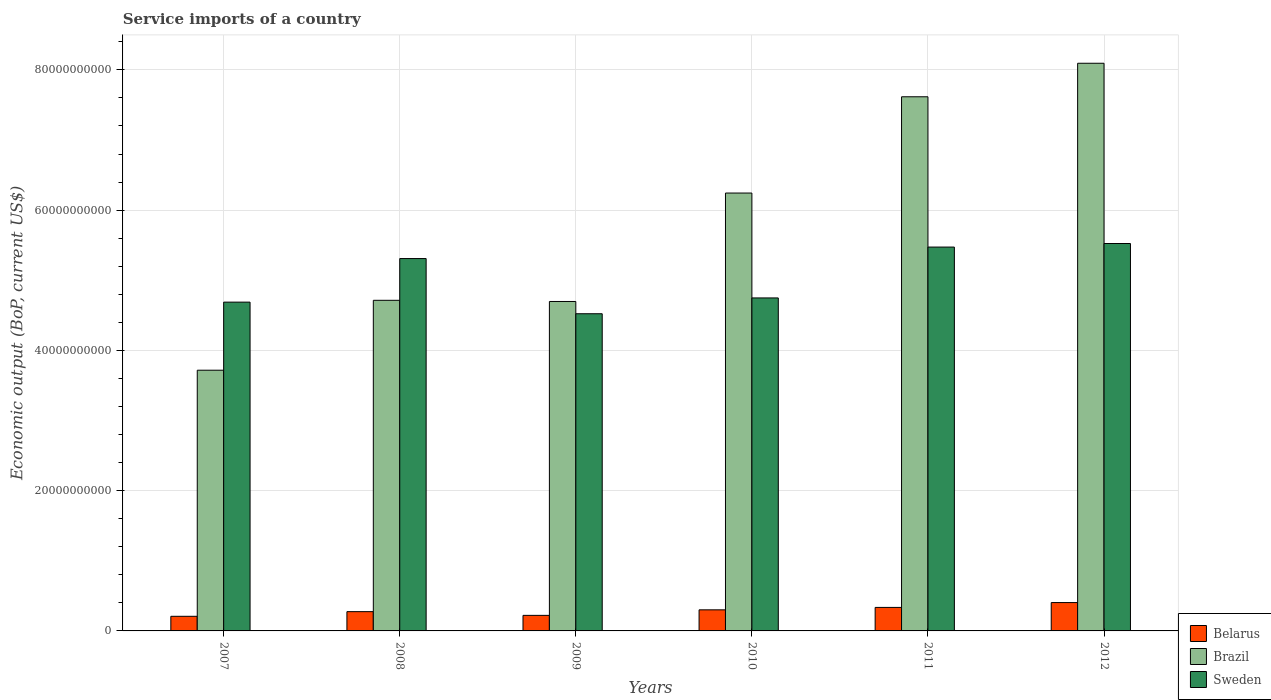How many groups of bars are there?
Give a very brief answer. 6. Are the number of bars on each tick of the X-axis equal?
Your response must be concise. Yes. How many bars are there on the 1st tick from the left?
Provide a short and direct response. 3. How many bars are there on the 4th tick from the right?
Your response must be concise. 3. What is the service imports in Sweden in 2007?
Provide a short and direct response. 4.69e+1. Across all years, what is the maximum service imports in Sweden?
Your answer should be very brief. 5.52e+1. Across all years, what is the minimum service imports in Brazil?
Offer a terse response. 3.72e+1. In which year was the service imports in Belarus maximum?
Your answer should be compact. 2012. What is the total service imports in Brazil in the graph?
Provide a short and direct response. 3.51e+11. What is the difference between the service imports in Brazil in 2009 and that in 2010?
Make the answer very short. -1.55e+1. What is the difference between the service imports in Belarus in 2011 and the service imports in Brazil in 2009?
Make the answer very short. -4.36e+1. What is the average service imports in Belarus per year?
Give a very brief answer. 2.91e+09. In the year 2007, what is the difference between the service imports in Belarus and service imports in Brazil?
Offer a terse response. -3.51e+1. What is the ratio of the service imports in Belarus in 2008 to that in 2009?
Offer a terse response. 1.24. Is the service imports in Belarus in 2009 less than that in 2011?
Keep it short and to the point. Yes. What is the difference between the highest and the second highest service imports in Brazil?
Keep it short and to the point. 4.78e+09. What is the difference between the highest and the lowest service imports in Belarus?
Offer a terse response. 1.96e+09. In how many years, is the service imports in Brazil greater than the average service imports in Brazil taken over all years?
Provide a short and direct response. 3. What does the 1st bar from the left in 2010 represents?
Your response must be concise. Belarus. Is it the case that in every year, the sum of the service imports in Belarus and service imports in Sweden is greater than the service imports in Brazil?
Ensure brevity in your answer.  No. How many bars are there?
Your answer should be compact. 18. Are all the bars in the graph horizontal?
Your answer should be compact. No. Does the graph contain grids?
Give a very brief answer. Yes. How are the legend labels stacked?
Give a very brief answer. Vertical. What is the title of the graph?
Your response must be concise. Service imports of a country. Does "Mali" appear as one of the legend labels in the graph?
Give a very brief answer. No. What is the label or title of the Y-axis?
Your response must be concise. Economic output (BoP, current US$). What is the Economic output (BoP, current US$) in Belarus in 2007?
Your answer should be compact. 2.08e+09. What is the Economic output (BoP, current US$) in Brazil in 2007?
Make the answer very short. 3.72e+1. What is the Economic output (BoP, current US$) in Sweden in 2007?
Offer a very short reply. 4.69e+1. What is the Economic output (BoP, current US$) of Belarus in 2008?
Your response must be concise. 2.75e+09. What is the Economic output (BoP, current US$) of Brazil in 2008?
Your response must be concise. 4.71e+1. What is the Economic output (BoP, current US$) of Sweden in 2008?
Provide a short and direct response. 5.31e+1. What is the Economic output (BoP, current US$) in Belarus in 2009?
Ensure brevity in your answer.  2.22e+09. What is the Economic output (BoP, current US$) of Brazil in 2009?
Your response must be concise. 4.70e+1. What is the Economic output (BoP, current US$) of Sweden in 2009?
Offer a very short reply. 4.52e+1. What is the Economic output (BoP, current US$) in Belarus in 2010?
Ensure brevity in your answer.  3.01e+09. What is the Economic output (BoP, current US$) in Brazil in 2010?
Ensure brevity in your answer.  6.24e+1. What is the Economic output (BoP, current US$) of Sweden in 2010?
Make the answer very short. 4.75e+1. What is the Economic output (BoP, current US$) of Belarus in 2011?
Offer a terse response. 3.35e+09. What is the Economic output (BoP, current US$) of Brazil in 2011?
Give a very brief answer. 7.62e+1. What is the Economic output (BoP, current US$) in Sweden in 2011?
Offer a terse response. 5.47e+1. What is the Economic output (BoP, current US$) in Belarus in 2012?
Offer a very short reply. 4.04e+09. What is the Economic output (BoP, current US$) of Brazil in 2012?
Provide a short and direct response. 8.09e+1. What is the Economic output (BoP, current US$) in Sweden in 2012?
Your answer should be very brief. 5.52e+1. Across all years, what is the maximum Economic output (BoP, current US$) of Belarus?
Your response must be concise. 4.04e+09. Across all years, what is the maximum Economic output (BoP, current US$) of Brazil?
Offer a terse response. 8.09e+1. Across all years, what is the maximum Economic output (BoP, current US$) in Sweden?
Give a very brief answer. 5.52e+1. Across all years, what is the minimum Economic output (BoP, current US$) in Belarus?
Your answer should be compact. 2.08e+09. Across all years, what is the minimum Economic output (BoP, current US$) of Brazil?
Your answer should be compact. 3.72e+1. Across all years, what is the minimum Economic output (BoP, current US$) in Sweden?
Your answer should be compact. 4.52e+1. What is the total Economic output (BoP, current US$) in Belarus in the graph?
Your response must be concise. 1.75e+1. What is the total Economic output (BoP, current US$) in Brazil in the graph?
Offer a very short reply. 3.51e+11. What is the total Economic output (BoP, current US$) in Sweden in the graph?
Your answer should be very brief. 3.03e+11. What is the difference between the Economic output (BoP, current US$) of Belarus in 2007 and that in 2008?
Offer a terse response. -6.63e+08. What is the difference between the Economic output (BoP, current US$) of Brazil in 2007 and that in 2008?
Your answer should be compact. -9.97e+09. What is the difference between the Economic output (BoP, current US$) of Sweden in 2007 and that in 2008?
Make the answer very short. -6.21e+09. What is the difference between the Economic output (BoP, current US$) of Belarus in 2007 and that in 2009?
Make the answer very short. -1.33e+08. What is the difference between the Economic output (BoP, current US$) of Brazil in 2007 and that in 2009?
Your answer should be compact. -9.80e+09. What is the difference between the Economic output (BoP, current US$) in Sweden in 2007 and that in 2009?
Your response must be concise. 1.65e+09. What is the difference between the Economic output (BoP, current US$) in Belarus in 2007 and that in 2010?
Give a very brief answer. -9.22e+08. What is the difference between the Economic output (BoP, current US$) in Brazil in 2007 and that in 2010?
Your answer should be compact. -2.53e+1. What is the difference between the Economic output (BoP, current US$) of Sweden in 2007 and that in 2010?
Offer a terse response. -5.99e+08. What is the difference between the Economic output (BoP, current US$) of Belarus in 2007 and that in 2011?
Ensure brevity in your answer.  -1.27e+09. What is the difference between the Economic output (BoP, current US$) in Brazil in 2007 and that in 2011?
Offer a terse response. -3.90e+1. What is the difference between the Economic output (BoP, current US$) in Sweden in 2007 and that in 2011?
Offer a terse response. -7.85e+09. What is the difference between the Economic output (BoP, current US$) of Belarus in 2007 and that in 2012?
Ensure brevity in your answer.  -1.96e+09. What is the difference between the Economic output (BoP, current US$) in Brazil in 2007 and that in 2012?
Make the answer very short. -4.38e+1. What is the difference between the Economic output (BoP, current US$) of Sweden in 2007 and that in 2012?
Your response must be concise. -8.36e+09. What is the difference between the Economic output (BoP, current US$) of Belarus in 2008 and that in 2009?
Keep it short and to the point. 5.30e+08. What is the difference between the Economic output (BoP, current US$) of Brazil in 2008 and that in 2009?
Offer a terse response. 1.66e+08. What is the difference between the Economic output (BoP, current US$) in Sweden in 2008 and that in 2009?
Offer a very short reply. 7.87e+09. What is the difference between the Economic output (BoP, current US$) in Belarus in 2008 and that in 2010?
Ensure brevity in your answer.  -2.59e+08. What is the difference between the Economic output (BoP, current US$) in Brazil in 2008 and that in 2010?
Give a very brief answer. -1.53e+1. What is the difference between the Economic output (BoP, current US$) of Sweden in 2008 and that in 2010?
Offer a very short reply. 5.61e+09. What is the difference between the Economic output (BoP, current US$) of Belarus in 2008 and that in 2011?
Your answer should be very brief. -6.04e+08. What is the difference between the Economic output (BoP, current US$) of Brazil in 2008 and that in 2011?
Make the answer very short. -2.90e+1. What is the difference between the Economic output (BoP, current US$) in Sweden in 2008 and that in 2011?
Give a very brief answer. -1.64e+09. What is the difference between the Economic output (BoP, current US$) in Belarus in 2008 and that in 2012?
Offer a very short reply. -1.30e+09. What is the difference between the Economic output (BoP, current US$) of Brazil in 2008 and that in 2012?
Make the answer very short. -3.38e+1. What is the difference between the Economic output (BoP, current US$) of Sweden in 2008 and that in 2012?
Give a very brief answer. -2.15e+09. What is the difference between the Economic output (BoP, current US$) in Belarus in 2009 and that in 2010?
Your response must be concise. -7.89e+08. What is the difference between the Economic output (BoP, current US$) in Brazil in 2009 and that in 2010?
Offer a very short reply. -1.55e+1. What is the difference between the Economic output (BoP, current US$) in Sweden in 2009 and that in 2010?
Offer a very short reply. -2.25e+09. What is the difference between the Economic output (BoP, current US$) of Belarus in 2009 and that in 2011?
Make the answer very short. -1.13e+09. What is the difference between the Economic output (BoP, current US$) of Brazil in 2009 and that in 2011?
Provide a short and direct response. -2.92e+1. What is the difference between the Economic output (BoP, current US$) of Sweden in 2009 and that in 2011?
Offer a terse response. -9.51e+09. What is the difference between the Economic output (BoP, current US$) of Belarus in 2009 and that in 2012?
Keep it short and to the point. -1.83e+09. What is the difference between the Economic output (BoP, current US$) in Brazil in 2009 and that in 2012?
Ensure brevity in your answer.  -3.40e+1. What is the difference between the Economic output (BoP, current US$) of Sweden in 2009 and that in 2012?
Your response must be concise. -1.00e+1. What is the difference between the Economic output (BoP, current US$) in Belarus in 2010 and that in 2011?
Offer a very short reply. -3.45e+08. What is the difference between the Economic output (BoP, current US$) of Brazil in 2010 and that in 2011?
Your answer should be compact. -1.37e+1. What is the difference between the Economic output (BoP, current US$) in Sweden in 2010 and that in 2011?
Your response must be concise. -7.25e+09. What is the difference between the Economic output (BoP, current US$) of Belarus in 2010 and that in 2012?
Keep it short and to the point. -1.04e+09. What is the difference between the Economic output (BoP, current US$) of Brazil in 2010 and that in 2012?
Ensure brevity in your answer.  -1.85e+1. What is the difference between the Economic output (BoP, current US$) in Sweden in 2010 and that in 2012?
Your response must be concise. -7.76e+09. What is the difference between the Economic output (BoP, current US$) of Belarus in 2011 and that in 2012?
Your answer should be very brief. -6.92e+08. What is the difference between the Economic output (BoP, current US$) of Brazil in 2011 and that in 2012?
Give a very brief answer. -4.78e+09. What is the difference between the Economic output (BoP, current US$) of Sweden in 2011 and that in 2012?
Offer a very short reply. -5.08e+08. What is the difference between the Economic output (BoP, current US$) in Belarus in 2007 and the Economic output (BoP, current US$) in Brazil in 2008?
Offer a terse response. -4.51e+1. What is the difference between the Economic output (BoP, current US$) of Belarus in 2007 and the Economic output (BoP, current US$) of Sweden in 2008?
Give a very brief answer. -5.10e+1. What is the difference between the Economic output (BoP, current US$) in Brazil in 2007 and the Economic output (BoP, current US$) in Sweden in 2008?
Make the answer very short. -1.59e+1. What is the difference between the Economic output (BoP, current US$) in Belarus in 2007 and the Economic output (BoP, current US$) in Brazil in 2009?
Your answer should be compact. -4.49e+1. What is the difference between the Economic output (BoP, current US$) in Belarus in 2007 and the Economic output (BoP, current US$) in Sweden in 2009?
Provide a succinct answer. -4.31e+1. What is the difference between the Economic output (BoP, current US$) of Brazil in 2007 and the Economic output (BoP, current US$) of Sweden in 2009?
Your response must be concise. -8.05e+09. What is the difference between the Economic output (BoP, current US$) of Belarus in 2007 and the Economic output (BoP, current US$) of Brazil in 2010?
Offer a terse response. -6.03e+1. What is the difference between the Economic output (BoP, current US$) of Belarus in 2007 and the Economic output (BoP, current US$) of Sweden in 2010?
Provide a short and direct response. -4.54e+1. What is the difference between the Economic output (BoP, current US$) of Brazil in 2007 and the Economic output (BoP, current US$) of Sweden in 2010?
Keep it short and to the point. -1.03e+1. What is the difference between the Economic output (BoP, current US$) in Belarus in 2007 and the Economic output (BoP, current US$) in Brazil in 2011?
Keep it short and to the point. -7.41e+1. What is the difference between the Economic output (BoP, current US$) of Belarus in 2007 and the Economic output (BoP, current US$) of Sweden in 2011?
Your answer should be compact. -5.26e+1. What is the difference between the Economic output (BoP, current US$) of Brazil in 2007 and the Economic output (BoP, current US$) of Sweden in 2011?
Your answer should be compact. -1.76e+1. What is the difference between the Economic output (BoP, current US$) in Belarus in 2007 and the Economic output (BoP, current US$) in Brazil in 2012?
Provide a succinct answer. -7.89e+1. What is the difference between the Economic output (BoP, current US$) in Belarus in 2007 and the Economic output (BoP, current US$) in Sweden in 2012?
Offer a terse response. -5.32e+1. What is the difference between the Economic output (BoP, current US$) in Brazil in 2007 and the Economic output (BoP, current US$) in Sweden in 2012?
Your answer should be compact. -1.81e+1. What is the difference between the Economic output (BoP, current US$) in Belarus in 2008 and the Economic output (BoP, current US$) in Brazil in 2009?
Provide a succinct answer. -4.42e+1. What is the difference between the Economic output (BoP, current US$) of Belarus in 2008 and the Economic output (BoP, current US$) of Sweden in 2009?
Offer a very short reply. -4.25e+1. What is the difference between the Economic output (BoP, current US$) of Brazil in 2008 and the Economic output (BoP, current US$) of Sweden in 2009?
Keep it short and to the point. 1.92e+09. What is the difference between the Economic output (BoP, current US$) of Belarus in 2008 and the Economic output (BoP, current US$) of Brazil in 2010?
Your answer should be compact. -5.97e+1. What is the difference between the Economic output (BoP, current US$) in Belarus in 2008 and the Economic output (BoP, current US$) in Sweden in 2010?
Give a very brief answer. -4.47e+1. What is the difference between the Economic output (BoP, current US$) of Brazil in 2008 and the Economic output (BoP, current US$) of Sweden in 2010?
Give a very brief answer. -3.39e+08. What is the difference between the Economic output (BoP, current US$) in Belarus in 2008 and the Economic output (BoP, current US$) in Brazil in 2011?
Ensure brevity in your answer.  -7.34e+1. What is the difference between the Economic output (BoP, current US$) of Belarus in 2008 and the Economic output (BoP, current US$) of Sweden in 2011?
Provide a short and direct response. -5.20e+1. What is the difference between the Economic output (BoP, current US$) in Brazil in 2008 and the Economic output (BoP, current US$) in Sweden in 2011?
Give a very brief answer. -7.59e+09. What is the difference between the Economic output (BoP, current US$) in Belarus in 2008 and the Economic output (BoP, current US$) in Brazil in 2012?
Offer a terse response. -7.82e+1. What is the difference between the Economic output (BoP, current US$) in Belarus in 2008 and the Economic output (BoP, current US$) in Sweden in 2012?
Ensure brevity in your answer.  -5.25e+1. What is the difference between the Economic output (BoP, current US$) of Brazil in 2008 and the Economic output (BoP, current US$) of Sweden in 2012?
Make the answer very short. -8.10e+09. What is the difference between the Economic output (BoP, current US$) of Belarus in 2009 and the Economic output (BoP, current US$) of Brazil in 2010?
Offer a terse response. -6.02e+1. What is the difference between the Economic output (BoP, current US$) of Belarus in 2009 and the Economic output (BoP, current US$) of Sweden in 2010?
Give a very brief answer. -4.53e+1. What is the difference between the Economic output (BoP, current US$) of Brazil in 2009 and the Economic output (BoP, current US$) of Sweden in 2010?
Your answer should be compact. -5.05e+08. What is the difference between the Economic output (BoP, current US$) in Belarus in 2009 and the Economic output (BoP, current US$) in Brazil in 2011?
Your answer should be very brief. -7.39e+1. What is the difference between the Economic output (BoP, current US$) in Belarus in 2009 and the Economic output (BoP, current US$) in Sweden in 2011?
Make the answer very short. -5.25e+1. What is the difference between the Economic output (BoP, current US$) in Brazil in 2009 and the Economic output (BoP, current US$) in Sweden in 2011?
Ensure brevity in your answer.  -7.76e+09. What is the difference between the Economic output (BoP, current US$) in Belarus in 2009 and the Economic output (BoP, current US$) in Brazil in 2012?
Offer a terse response. -7.87e+1. What is the difference between the Economic output (BoP, current US$) in Belarus in 2009 and the Economic output (BoP, current US$) in Sweden in 2012?
Your answer should be compact. -5.30e+1. What is the difference between the Economic output (BoP, current US$) of Brazil in 2009 and the Economic output (BoP, current US$) of Sweden in 2012?
Provide a succinct answer. -8.26e+09. What is the difference between the Economic output (BoP, current US$) in Belarus in 2010 and the Economic output (BoP, current US$) in Brazil in 2011?
Make the answer very short. -7.32e+1. What is the difference between the Economic output (BoP, current US$) in Belarus in 2010 and the Economic output (BoP, current US$) in Sweden in 2011?
Provide a succinct answer. -5.17e+1. What is the difference between the Economic output (BoP, current US$) of Brazil in 2010 and the Economic output (BoP, current US$) of Sweden in 2011?
Make the answer very short. 7.70e+09. What is the difference between the Economic output (BoP, current US$) in Belarus in 2010 and the Economic output (BoP, current US$) in Brazil in 2012?
Provide a succinct answer. -7.79e+1. What is the difference between the Economic output (BoP, current US$) in Belarus in 2010 and the Economic output (BoP, current US$) in Sweden in 2012?
Provide a short and direct response. -5.22e+1. What is the difference between the Economic output (BoP, current US$) in Brazil in 2010 and the Economic output (BoP, current US$) in Sweden in 2012?
Give a very brief answer. 7.20e+09. What is the difference between the Economic output (BoP, current US$) in Belarus in 2011 and the Economic output (BoP, current US$) in Brazil in 2012?
Offer a very short reply. -7.76e+1. What is the difference between the Economic output (BoP, current US$) of Belarus in 2011 and the Economic output (BoP, current US$) of Sweden in 2012?
Ensure brevity in your answer.  -5.19e+1. What is the difference between the Economic output (BoP, current US$) in Brazil in 2011 and the Economic output (BoP, current US$) in Sweden in 2012?
Keep it short and to the point. 2.09e+1. What is the average Economic output (BoP, current US$) in Belarus per year?
Your response must be concise. 2.91e+09. What is the average Economic output (BoP, current US$) in Brazil per year?
Provide a succinct answer. 5.85e+1. What is the average Economic output (BoP, current US$) in Sweden per year?
Offer a very short reply. 5.04e+1. In the year 2007, what is the difference between the Economic output (BoP, current US$) in Belarus and Economic output (BoP, current US$) in Brazil?
Your response must be concise. -3.51e+1. In the year 2007, what is the difference between the Economic output (BoP, current US$) in Belarus and Economic output (BoP, current US$) in Sweden?
Keep it short and to the point. -4.48e+1. In the year 2007, what is the difference between the Economic output (BoP, current US$) in Brazil and Economic output (BoP, current US$) in Sweden?
Your response must be concise. -9.71e+09. In the year 2008, what is the difference between the Economic output (BoP, current US$) of Belarus and Economic output (BoP, current US$) of Brazil?
Your response must be concise. -4.44e+1. In the year 2008, what is the difference between the Economic output (BoP, current US$) in Belarus and Economic output (BoP, current US$) in Sweden?
Provide a short and direct response. -5.03e+1. In the year 2008, what is the difference between the Economic output (BoP, current US$) in Brazil and Economic output (BoP, current US$) in Sweden?
Make the answer very short. -5.95e+09. In the year 2009, what is the difference between the Economic output (BoP, current US$) in Belarus and Economic output (BoP, current US$) in Brazil?
Offer a terse response. -4.48e+1. In the year 2009, what is the difference between the Economic output (BoP, current US$) of Belarus and Economic output (BoP, current US$) of Sweden?
Keep it short and to the point. -4.30e+1. In the year 2009, what is the difference between the Economic output (BoP, current US$) in Brazil and Economic output (BoP, current US$) in Sweden?
Your answer should be compact. 1.75e+09. In the year 2010, what is the difference between the Economic output (BoP, current US$) of Belarus and Economic output (BoP, current US$) of Brazil?
Your answer should be very brief. -5.94e+1. In the year 2010, what is the difference between the Economic output (BoP, current US$) of Belarus and Economic output (BoP, current US$) of Sweden?
Keep it short and to the point. -4.45e+1. In the year 2010, what is the difference between the Economic output (BoP, current US$) of Brazil and Economic output (BoP, current US$) of Sweden?
Provide a short and direct response. 1.50e+1. In the year 2011, what is the difference between the Economic output (BoP, current US$) of Belarus and Economic output (BoP, current US$) of Brazil?
Offer a very short reply. -7.28e+1. In the year 2011, what is the difference between the Economic output (BoP, current US$) of Belarus and Economic output (BoP, current US$) of Sweden?
Provide a succinct answer. -5.14e+1. In the year 2011, what is the difference between the Economic output (BoP, current US$) in Brazil and Economic output (BoP, current US$) in Sweden?
Offer a terse response. 2.14e+1. In the year 2012, what is the difference between the Economic output (BoP, current US$) of Belarus and Economic output (BoP, current US$) of Brazil?
Your answer should be very brief. -7.69e+1. In the year 2012, what is the difference between the Economic output (BoP, current US$) in Belarus and Economic output (BoP, current US$) in Sweden?
Keep it short and to the point. -5.12e+1. In the year 2012, what is the difference between the Economic output (BoP, current US$) of Brazil and Economic output (BoP, current US$) of Sweden?
Your answer should be compact. 2.57e+1. What is the ratio of the Economic output (BoP, current US$) of Belarus in 2007 to that in 2008?
Keep it short and to the point. 0.76. What is the ratio of the Economic output (BoP, current US$) in Brazil in 2007 to that in 2008?
Provide a succinct answer. 0.79. What is the ratio of the Economic output (BoP, current US$) of Sweden in 2007 to that in 2008?
Your answer should be compact. 0.88. What is the ratio of the Economic output (BoP, current US$) in Belarus in 2007 to that in 2009?
Your answer should be compact. 0.94. What is the ratio of the Economic output (BoP, current US$) in Brazil in 2007 to that in 2009?
Provide a succinct answer. 0.79. What is the ratio of the Economic output (BoP, current US$) of Sweden in 2007 to that in 2009?
Offer a very short reply. 1.04. What is the ratio of the Economic output (BoP, current US$) of Belarus in 2007 to that in 2010?
Provide a short and direct response. 0.69. What is the ratio of the Economic output (BoP, current US$) of Brazil in 2007 to that in 2010?
Ensure brevity in your answer.  0.6. What is the ratio of the Economic output (BoP, current US$) of Sweden in 2007 to that in 2010?
Give a very brief answer. 0.99. What is the ratio of the Economic output (BoP, current US$) of Belarus in 2007 to that in 2011?
Ensure brevity in your answer.  0.62. What is the ratio of the Economic output (BoP, current US$) in Brazil in 2007 to that in 2011?
Give a very brief answer. 0.49. What is the ratio of the Economic output (BoP, current US$) of Sweden in 2007 to that in 2011?
Your answer should be compact. 0.86. What is the ratio of the Economic output (BoP, current US$) of Belarus in 2007 to that in 2012?
Offer a very short reply. 0.52. What is the ratio of the Economic output (BoP, current US$) in Brazil in 2007 to that in 2012?
Offer a very short reply. 0.46. What is the ratio of the Economic output (BoP, current US$) of Sweden in 2007 to that in 2012?
Ensure brevity in your answer.  0.85. What is the ratio of the Economic output (BoP, current US$) of Belarus in 2008 to that in 2009?
Ensure brevity in your answer.  1.24. What is the ratio of the Economic output (BoP, current US$) in Brazil in 2008 to that in 2009?
Make the answer very short. 1. What is the ratio of the Economic output (BoP, current US$) of Sweden in 2008 to that in 2009?
Ensure brevity in your answer.  1.17. What is the ratio of the Economic output (BoP, current US$) in Belarus in 2008 to that in 2010?
Your answer should be very brief. 0.91. What is the ratio of the Economic output (BoP, current US$) of Brazil in 2008 to that in 2010?
Ensure brevity in your answer.  0.76. What is the ratio of the Economic output (BoP, current US$) in Sweden in 2008 to that in 2010?
Your answer should be very brief. 1.12. What is the ratio of the Economic output (BoP, current US$) of Belarus in 2008 to that in 2011?
Give a very brief answer. 0.82. What is the ratio of the Economic output (BoP, current US$) in Brazil in 2008 to that in 2011?
Give a very brief answer. 0.62. What is the ratio of the Economic output (BoP, current US$) of Sweden in 2008 to that in 2011?
Make the answer very short. 0.97. What is the ratio of the Economic output (BoP, current US$) of Belarus in 2008 to that in 2012?
Your answer should be compact. 0.68. What is the ratio of the Economic output (BoP, current US$) in Brazil in 2008 to that in 2012?
Your answer should be very brief. 0.58. What is the ratio of the Economic output (BoP, current US$) of Sweden in 2008 to that in 2012?
Ensure brevity in your answer.  0.96. What is the ratio of the Economic output (BoP, current US$) of Belarus in 2009 to that in 2010?
Your answer should be very brief. 0.74. What is the ratio of the Economic output (BoP, current US$) of Brazil in 2009 to that in 2010?
Offer a very short reply. 0.75. What is the ratio of the Economic output (BoP, current US$) of Sweden in 2009 to that in 2010?
Make the answer very short. 0.95. What is the ratio of the Economic output (BoP, current US$) of Belarus in 2009 to that in 2011?
Your answer should be very brief. 0.66. What is the ratio of the Economic output (BoP, current US$) of Brazil in 2009 to that in 2011?
Offer a terse response. 0.62. What is the ratio of the Economic output (BoP, current US$) of Sweden in 2009 to that in 2011?
Your answer should be compact. 0.83. What is the ratio of the Economic output (BoP, current US$) in Belarus in 2009 to that in 2012?
Make the answer very short. 0.55. What is the ratio of the Economic output (BoP, current US$) in Brazil in 2009 to that in 2012?
Ensure brevity in your answer.  0.58. What is the ratio of the Economic output (BoP, current US$) of Sweden in 2009 to that in 2012?
Your answer should be compact. 0.82. What is the ratio of the Economic output (BoP, current US$) in Belarus in 2010 to that in 2011?
Offer a very short reply. 0.9. What is the ratio of the Economic output (BoP, current US$) in Brazil in 2010 to that in 2011?
Your answer should be very brief. 0.82. What is the ratio of the Economic output (BoP, current US$) of Sweden in 2010 to that in 2011?
Your answer should be very brief. 0.87. What is the ratio of the Economic output (BoP, current US$) in Belarus in 2010 to that in 2012?
Ensure brevity in your answer.  0.74. What is the ratio of the Economic output (BoP, current US$) in Brazil in 2010 to that in 2012?
Offer a very short reply. 0.77. What is the ratio of the Economic output (BoP, current US$) in Sweden in 2010 to that in 2012?
Provide a succinct answer. 0.86. What is the ratio of the Economic output (BoP, current US$) of Belarus in 2011 to that in 2012?
Provide a succinct answer. 0.83. What is the ratio of the Economic output (BoP, current US$) in Brazil in 2011 to that in 2012?
Give a very brief answer. 0.94. What is the difference between the highest and the second highest Economic output (BoP, current US$) in Belarus?
Offer a very short reply. 6.92e+08. What is the difference between the highest and the second highest Economic output (BoP, current US$) of Brazil?
Make the answer very short. 4.78e+09. What is the difference between the highest and the second highest Economic output (BoP, current US$) of Sweden?
Offer a very short reply. 5.08e+08. What is the difference between the highest and the lowest Economic output (BoP, current US$) of Belarus?
Offer a very short reply. 1.96e+09. What is the difference between the highest and the lowest Economic output (BoP, current US$) in Brazil?
Your response must be concise. 4.38e+1. What is the difference between the highest and the lowest Economic output (BoP, current US$) of Sweden?
Offer a very short reply. 1.00e+1. 